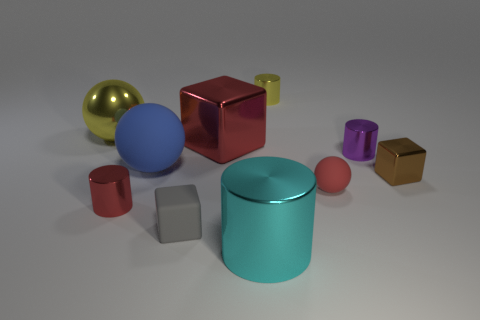Subtract all tiny gray matte cubes. How many cubes are left? 2 Subtract 0 yellow cubes. How many objects are left? 10 Subtract all cylinders. How many objects are left? 6 Subtract 1 cylinders. How many cylinders are left? 3 Subtract all gray cylinders. Subtract all green cubes. How many cylinders are left? 4 Subtract all gray cylinders. How many red blocks are left? 1 Subtract all tiny metal blocks. Subtract all large cylinders. How many objects are left? 8 Add 2 small yellow objects. How many small yellow objects are left? 3 Add 1 cyan metallic things. How many cyan metallic things exist? 2 Subtract all red spheres. How many spheres are left? 2 